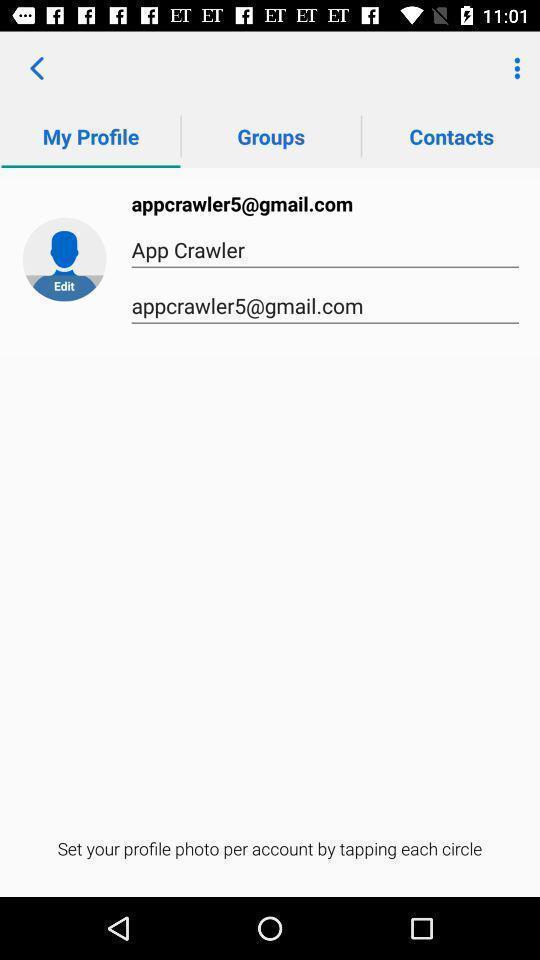Please provide a description for this image. Window displaying to set profile picture. 